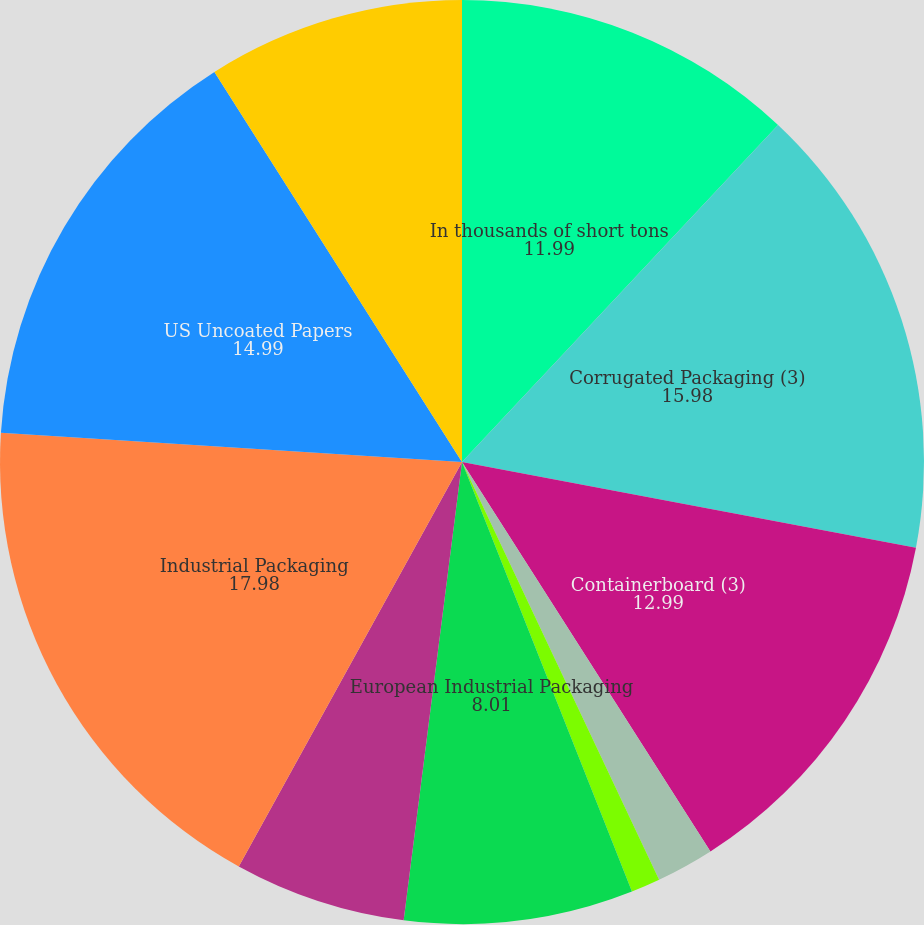Convert chart. <chart><loc_0><loc_0><loc_500><loc_500><pie_chart><fcel>In thousands of short tons<fcel>Corrugated Packaging (3)<fcel>Containerboard (3)<fcel>Saturated Kraft<fcel>Bleached Kraft<fcel>European Industrial Packaging<fcel>Asian Industrial Packaging<fcel>Industrial Packaging<fcel>US Uncoated Papers<fcel>European and Russian Uncoated<nl><fcel>11.99%<fcel>15.98%<fcel>12.99%<fcel>2.02%<fcel>1.02%<fcel>8.01%<fcel>6.01%<fcel>17.98%<fcel>14.99%<fcel>9.0%<nl></chart> 